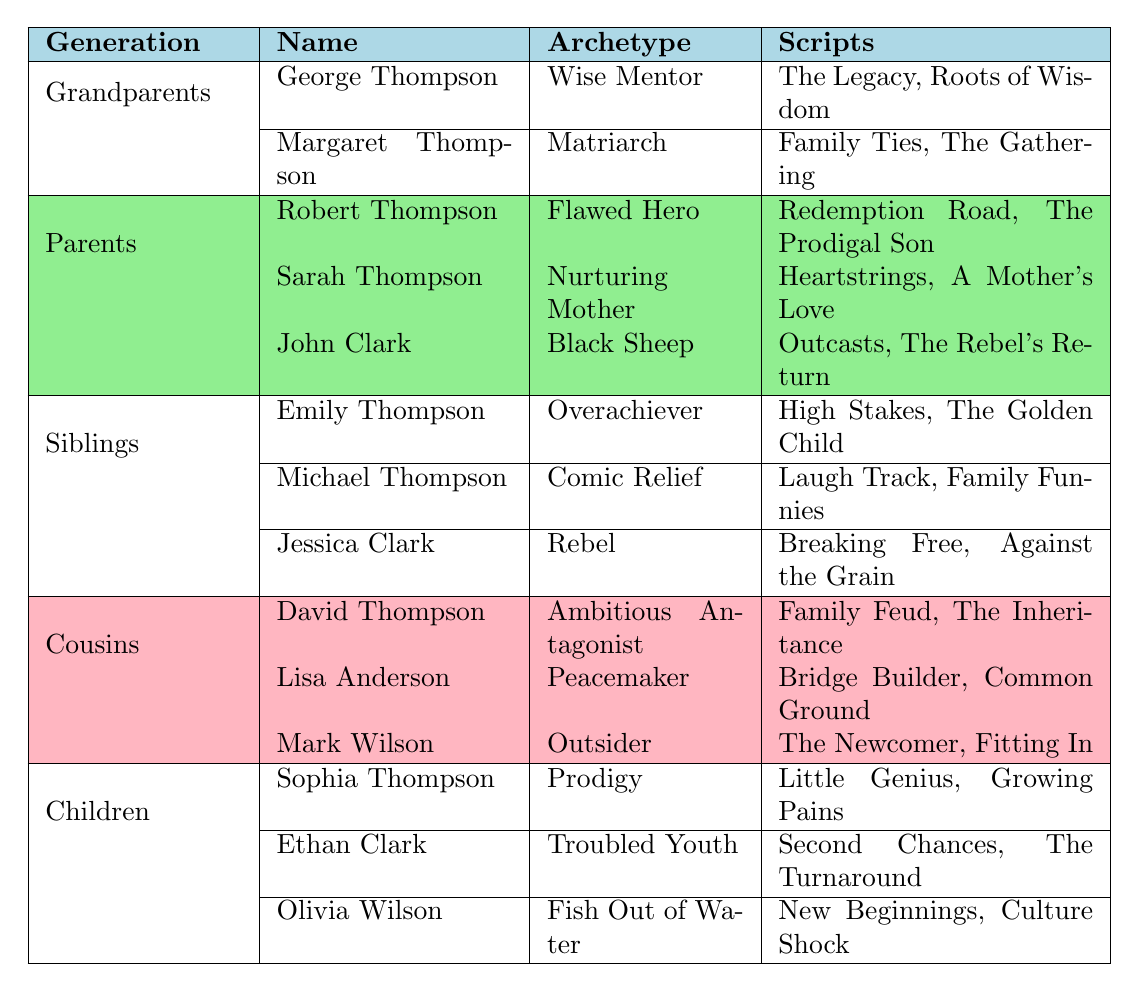What archetype is associated with George Thompson? George Thompson's archetype is listed directly under his name in the table, which is "Wise Mentor."
Answer: Wise Mentor How many scripts is Robert Thompson associated with? Robert Thompson is connected to two scripts: "Redemption Road" and "The Prodigal Son," as shown in the corresponding table row.
Answer: 2 Which character archetype appears most among the siblings? The sibling archetypes listed are Overachiever, Comic Relief, and Rebel, and there is no repetition; thus, each archetype appears once.
Answer: None Is Sarah Thompson a Matriarch? Sarah Thompson’s archetype is not Matriarch; according to the table, her archetype is "Nurturing Mother."
Answer: No Which generation does the character Mark Wilson belong to? Mark Wilson is categorized under the "Cousins" generation in the table.
Answer: Cousins What is the total number of characters listed across all generations in the table? There are 15 characters total from each generation: 2 grandparents, 3 parents, 3 siblings, 3 cousins, and 3 children, totaling 2 + 3 + 3 + 3 + 3 = 14.
Answer: 14 Which archetype is shared by both George Thompson and Margaret Thompson? Both characters have distinct archetypes; George is a "Wise Mentor," and Margaret is a "Matriarch," so there is no shared archetype.
Answer: None Are there any characters in the table with the archetype "Prodigy"? Looking through the table, only Sophia Thompson has the archetype labeled as "Prodigy."
Answer: Yes Who is the Nurturing Mother and in which generation does she belong? The Nurturing Mother is Sarah Thompson, and she is listed under the "Parents" generation of the table.
Answer: Sarah Thompson, Parents What is the primary archetype of characters in the "Children" generation? The children in this generation exhibit varying archetypes: Prodigy, Troubled Youth, and Fish Out of Water, showcasing a diverse set of qualities, so there is no primary archetype.
Answer: None (diverse archetypes) Do any of the parents share an archetype with one of the grandparents? The archetypes for parents are Flawed Hero, Nurturing Mother, and Black Sheep, and none of these match with Wise Mentor or Matriarch from the grandparents.
Answer: No 